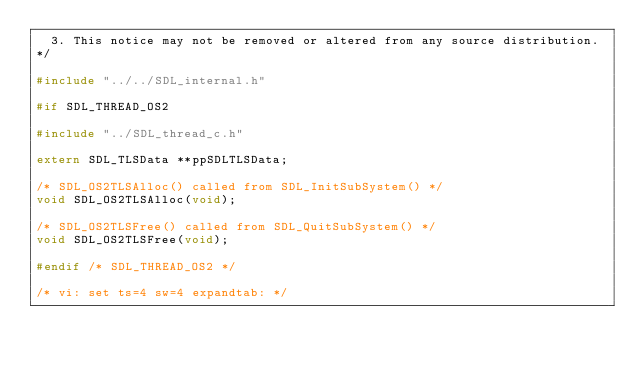<code> <loc_0><loc_0><loc_500><loc_500><_C_>  3. This notice may not be removed or altered from any source distribution.
*/

#include "../../SDL_internal.h"

#if SDL_THREAD_OS2

#include "../SDL_thread_c.h"

extern SDL_TLSData **ppSDLTLSData;

/* SDL_OS2TLSAlloc() called from SDL_InitSubSystem() */
void SDL_OS2TLSAlloc(void);

/* SDL_OS2TLSFree() called from SDL_QuitSubSystem() */
void SDL_OS2TLSFree(void);

#endif /* SDL_THREAD_OS2 */

/* vi: set ts=4 sw=4 expandtab: */
</code> 